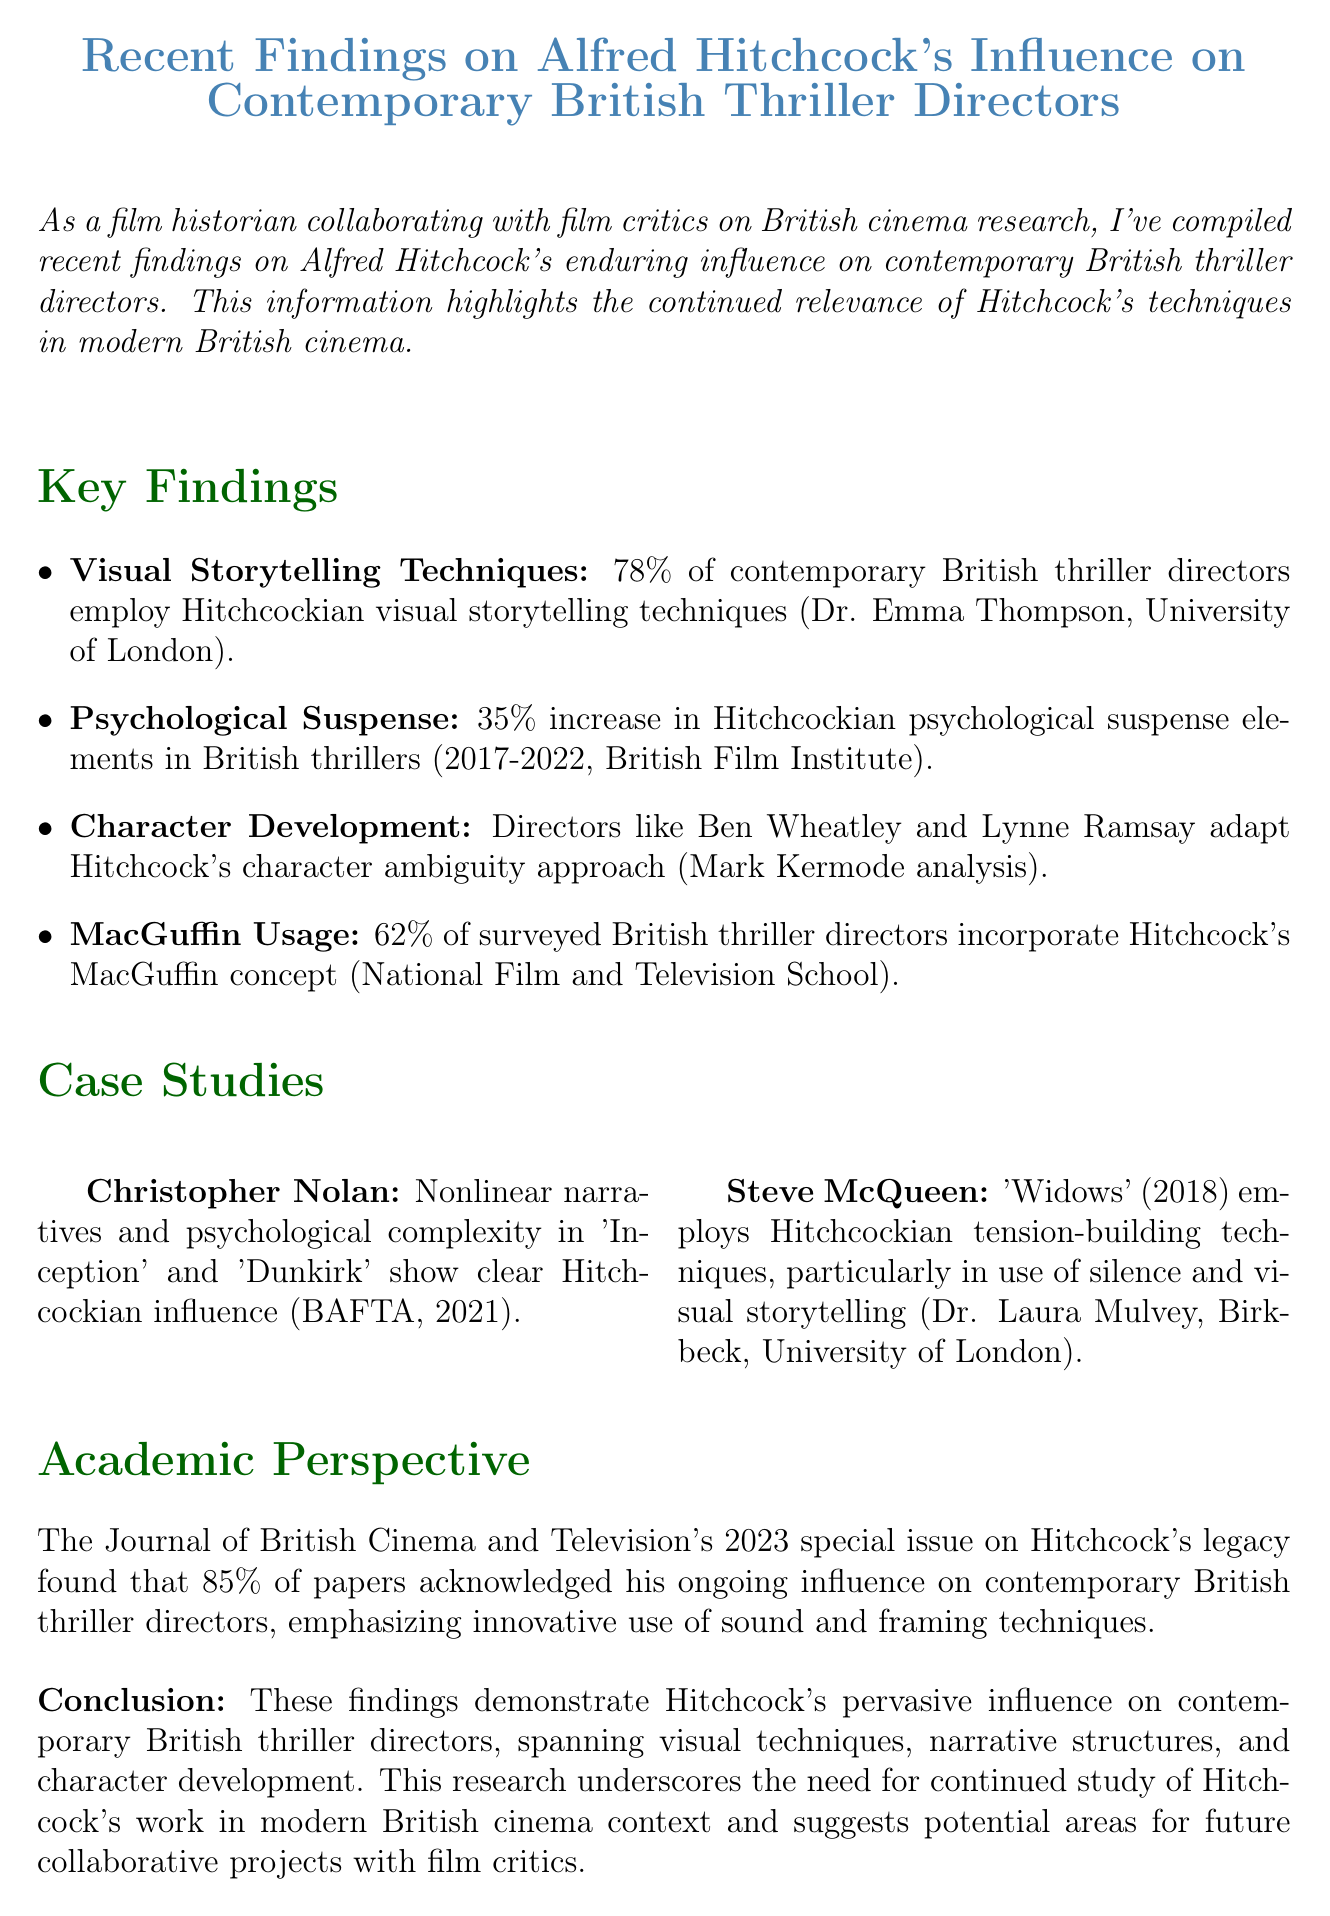What is the title of the memo? The title is stated at the beginning of the document, which summarizes the subject of the findings.
Answer: Recent Findings on Alfred Hitchcock's Influence on Contemporary British Thriller Directors Who conducted research on visual storytelling techniques? The document attributes the findings on visual storytelling techniques to a specific researcher and their institution.
Answer: Dr. Emma Thompson at the University of London What percentage of directors use Hitchcockian visual techniques? The document provides a statistic regarding directors that use specific technical methods derived from Hitchcock's work.
Answer: 78% Which director is noted for nonlinear narratives? The memo discusses a specific director known for this storytelling style, highlighted in a case study.
Answer: Christopher Nolan What increase in psychological suspense elements was reported? The document mentions a percentage increase concerning a specific aspect of thriller films over a set period.
Answer: 35% What concept do 62% of directors incorporate in their plots? The memo outlines a significant concept introduced by Hitchcock that many modern directors still integrate into their narratives.
Answer: MacGuffin What year did the British Film Institute report on thriller genres? The document refers to a specific year in which a report related to thriller elements was published.
Answer: 2022 What is emphasized in the Journal of British Cinema and Television's special issue? The memo summarizes a key finding from an academic perspective that highlights a significant aspect of Hitchcock's influence.
Answer: Innovative use of sound and framing techniques Which director's work is associated with silence and visual storytelling? A particular director is mentioned regarding their effective use of specific techniques in one of their films.
Answer: Steve McQueen 